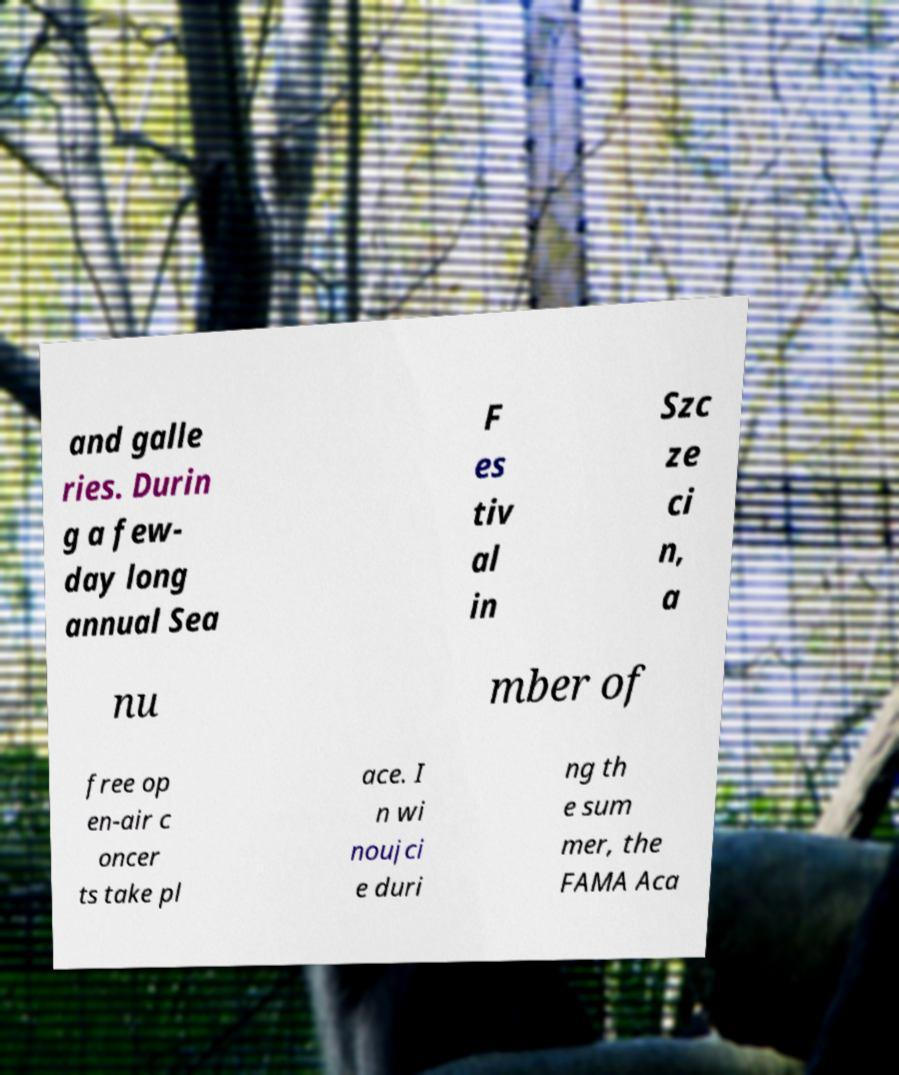Can you read and provide the text displayed in the image?This photo seems to have some interesting text. Can you extract and type it out for me? and galle ries. Durin g a few- day long annual Sea F es tiv al in Szc ze ci n, a nu mber of free op en-air c oncer ts take pl ace. I n wi noujci e duri ng th e sum mer, the FAMA Aca 